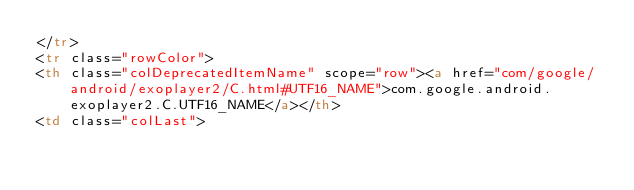Convert code to text. <code><loc_0><loc_0><loc_500><loc_500><_HTML_></tr>
<tr class="rowColor">
<th class="colDeprecatedItemName" scope="row"><a href="com/google/android/exoplayer2/C.html#UTF16_NAME">com.google.android.exoplayer2.C.UTF16_NAME</a></th>
<td class="colLast"></code> 